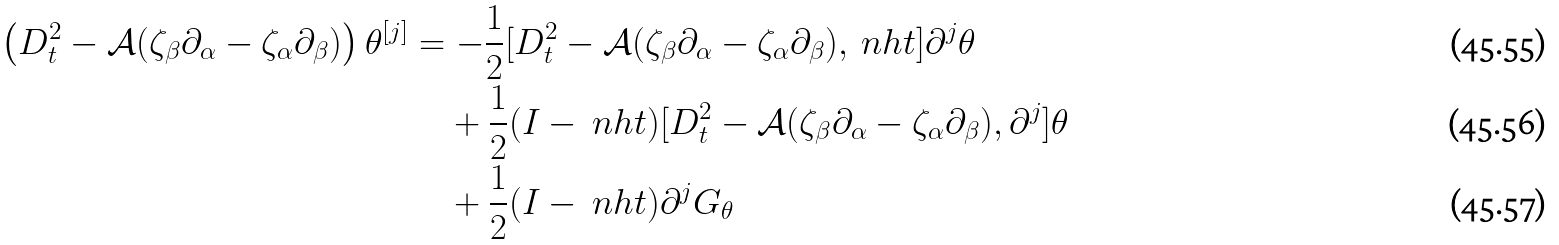Convert formula to latex. <formula><loc_0><loc_0><loc_500><loc_500>\left ( D _ { t } ^ { 2 } - \mathcal { A } ( \zeta _ { \beta } \partial _ { \alpha } - \zeta _ { \alpha } \partial _ { \beta } ) \right ) \theta ^ { [ j ] } & = - \frac { 1 } { 2 } [ D _ { t } ^ { 2 } - \mathcal { A } ( \zeta _ { \beta } \partial _ { \alpha } - \zeta _ { \alpha } \partial _ { \beta } ) , \ n h t ] \partial ^ { j } \theta \\ & \quad + \frac { 1 } { 2 } ( I - \ n h t ) [ D _ { t } ^ { 2 } - \mathcal { A } ( \zeta _ { \beta } \partial _ { \alpha } - \zeta _ { \alpha } \partial _ { \beta } ) , \partial ^ { j } ] \theta \\ & \quad + \frac { 1 } { 2 } ( I - \ n h t ) \partial ^ { j } G _ { \theta }</formula> 